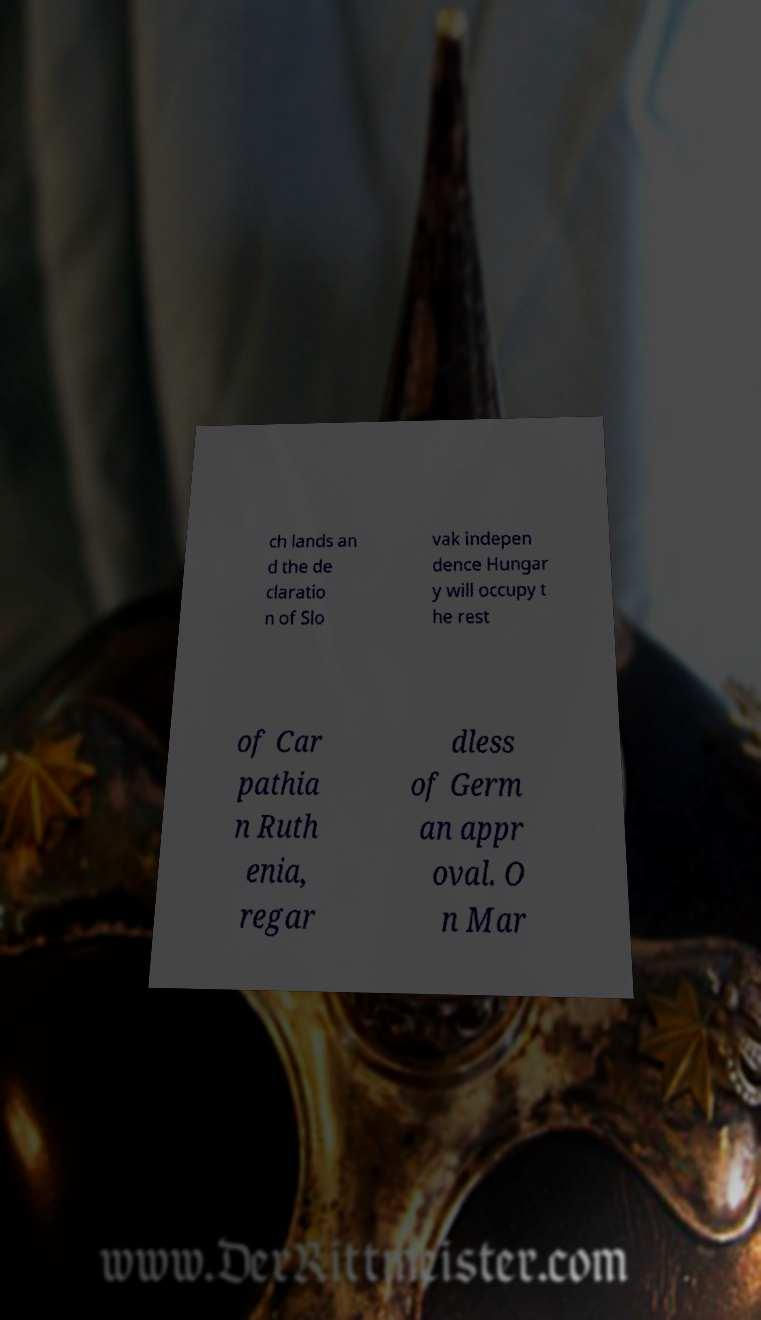Could you extract and type out the text from this image? ch lands an d the de claratio n of Slo vak indepen dence Hungar y will occupy t he rest of Car pathia n Ruth enia, regar dless of Germ an appr oval. O n Mar 